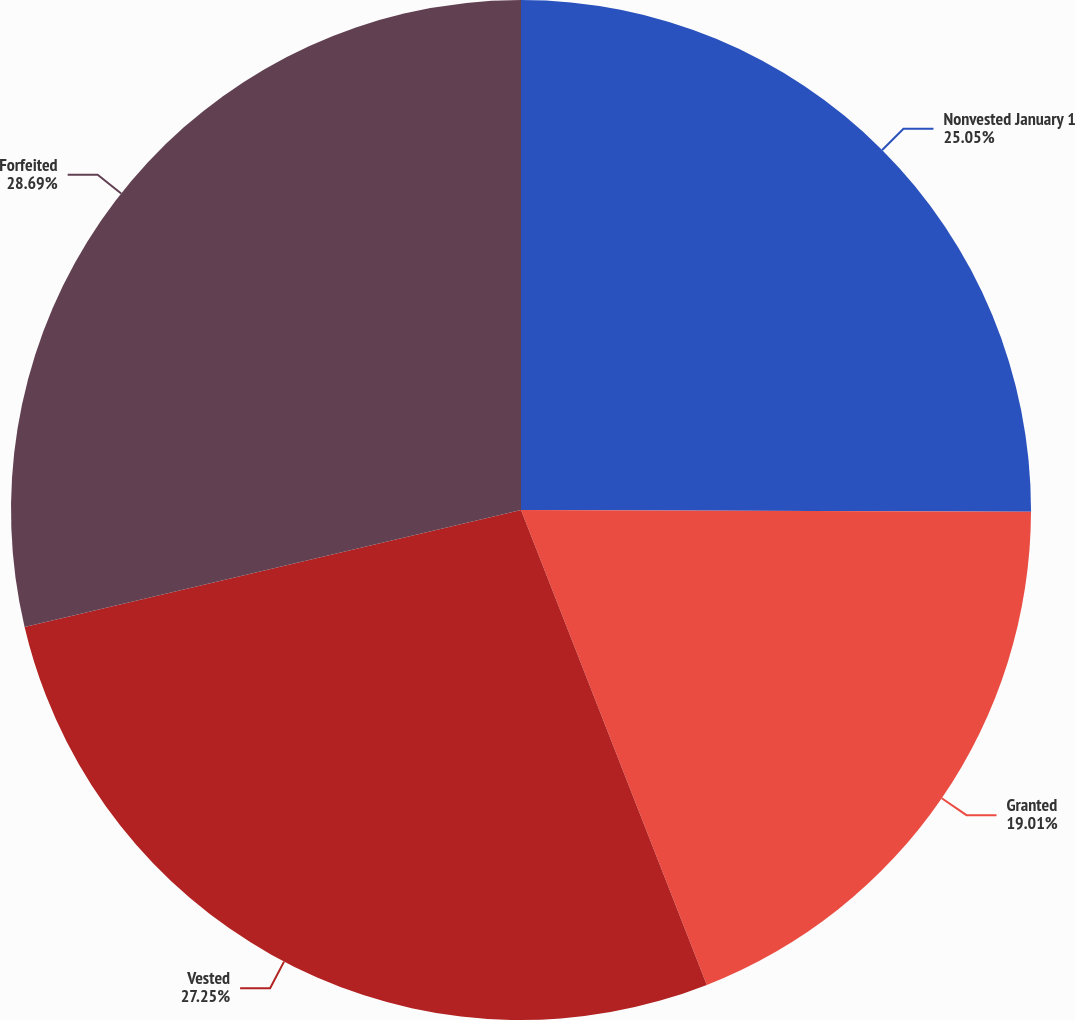<chart> <loc_0><loc_0><loc_500><loc_500><pie_chart><fcel>Nonvested January 1<fcel>Granted<fcel>Vested<fcel>Forfeited<nl><fcel>25.05%<fcel>19.01%<fcel>27.25%<fcel>28.68%<nl></chart> 